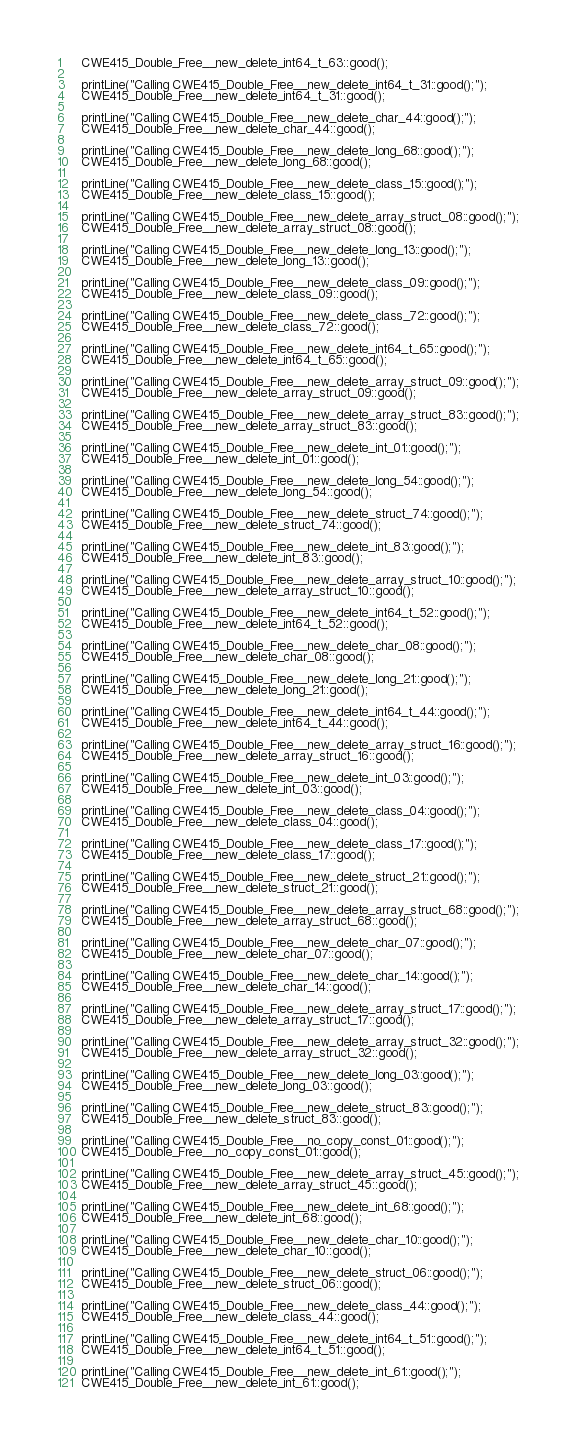<code> <loc_0><loc_0><loc_500><loc_500><_C++_>	CWE415_Double_Free__new_delete_int64_t_63::good();

	printLine("Calling CWE415_Double_Free__new_delete_int64_t_31::good();");
	CWE415_Double_Free__new_delete_int64_t_31::good();

	printLine("Calling CWE415_Double_Free__new_delete_char_44::good();");
	CWE415_Double_Free__new_delete_char_44::good();

	printLine("Calling CWE415_Double_Free__new_delete_long_68::good();");
	CWE415_Double_Free__new_delete_long_68::good();

	printLine("Calling CWE415_Double_Free__new_delete_class_15::good();");
	CWE415_Double_Free__new_delete_class_15::good();

	printLine("Calling CWE415_Double_Free__new_delete_array_struct_08::good();");
	CWE415_Double_Free__new_delete_array_struct_08::good();

	printLine("Calling CWE415_Double_Free__new_delete_long_13::good();");
	CWE415_Double_Free__new_delete_long_13::good();

	printLine("Calling CWE415_Double_Free__new_delete_class_09::good();");
	CWE415_Double_Free__new_delete_class_09::good();

	printLine("Calling CWE415_Double_Free__new_delete_class_72::good();");
	CWE415_Double_Free__new_delete_class_72::good();

	printLine("Calling CWE415_Double_Free__new_delete_int64_t_65::good();");
	CWE415_Double_Free__new_delete_int64_t_65::good();

	printLine("Calling CWE415_Double_Free__new_delete_array_struct_09::good();");
	CWE415_Double_Free__new_delete_array_struct_09::good();

	printLine("Calling CWE415_Double_Free__new_delete_array_struct_83::good();");
	CWE415_Double_Free__new_delete_array_struct_83::good();

	printLine("Calling CWE415_Double_Free__new_delete_int_01::good();");
	CWE415_Double_Free__new_delete_int_01::good();

	printLine("Calling CWE415_Double_Free__new_delete_long_54::good();");
	CWE415_Double_Free__new_delete_long_54::good();

	printLine("Calling CWE415_Double_Free__new_delete_struct_74::good();");
	CWE415_Double_Free__new_delete_struct_74::good();

	printLine("Calling CWE415_Double_Free__new_delete_int_83::good();");
	CWE415_Double_Free__new_delete_int_83::good();

	printLine("Calling CWE415_Double_Free__new_delete_array_struct_10::good();");
	CWE415_Double_Free__new_delete_array_struct_10::good();

	printLine("Calling CWE415_Double_Free__new_delete_int64_t_52::good();");
	CWE415_Double_Free__new_delete_int64_t_52::good();

	printLine("Calling CWE415_Double_Free__new_delete_char_08::good();");
	CWE415_Double_Free__new_delete_char_08::good();

	printLine("Calling CWE415_Double_Free__new_delete_long_21::good();");
	CWE415_Double_Free__new_delete_long_21::good();

	printLine("Calling CWE415_Double_Free__new_delete_int64_t_44::good();");
	CWE415_Double_Free__new_delete_int64_t_44::good();

	printLine("Calling CWE415_Double_Free__new_delete_array_struct_16::good();");
	CWE415_Double_Free__new_delete_array_struct_16::good();

	printLine("Calling CWE415_Double_Free__new_delete_int_03::good();");
	CWE415_Double_Free__new_delete_int_03::good();

	printLine("Calling CWE415_Double_Free__new_delete_class_04::good();");
	CWE415_Double_Free__new_delete_class_04::good();

	printLine("Calling CWE415_Double_Free__new_delete_class_17::good();");
	CWE415_Double_Free__new_delete_class_17::good();

	printLine("Calling CWE415_Double_Free__new_delete_struct_21::good();");
	CWE415_Double_Free__new_delete_struct_21::good();

	printLine("Calling CWE415_Double_Free__new_delete_array_struct_68::good();");
	CWE415_Double_Free__new_delete_array_struct_68::good();

	printLine("Calling CWE415_Double_Free__new_delete_char_07::good();");
	CWE415_Double_Free__new_delete_char_07::good();

	printLine("Calling CWE415_Double_Free__new_delete_char_14::good();");
	CWE415_Double_Free__new_delete_char_14::good();

	printLine("Calling CWE415_Double_Free__new_delete_array_struct_17::good();");
	CWE415_Double_Free__new_delete_array_struct_17::good();

	printLine("Calling CWE415_Double_Free__new_delete_array_struct_32::good();");
	CWE415_Double_Free__new_delete_array_struct_32::good();

	printLine("Calling CWE415_Double_Free__new_delete_long_03::good();");
	CWE415_Double_Free__new_delete_long_03::good();

	printLine("Calling CWE415_Double_Free__new_delete_struct_83::good();");
	CWE415_Double_Free__new_delete_struct_83::good();

	printLine("Calling CWE415_Double_Free__no_copy_const_01::good();");
	CWE415_Double_Free__no_copy_const_01::good();

	printLine("Calling CWE415_Double_Free__new_delete_array_struct_45::good();");
	CWE415_Double_Free__new_delete_array_struct_45::good();

	printLine("Calling CWE415_Double_Free__new_delete_int_68::good();");
	CWE415_Double_Free__new_delete_int_68::good();

	printLine("Calling CWE415_Double_Free__new_delete_char_10::good();");
	CWE415_Double_Free__new_delete_char_10::good();

	printLine("Calling CWE415_Double_Free__new_delete_struct_06::good();");
	CWE415_Double_Free__new_delete_struct_06::good();

	printLine("Calling CWE415_Double_Free__new_delete_class_44::good();");
	CWE415_Double_Free__new_delete_class_44::good();

	printLine("Calling CWE415_Double_Free__new_delete_int64_t_51::good();");
	CWE415_Double_Free__new_delete_int64_t_51::good();

	printLine("Calling CWE415_Double_Free__new_delete_int_61::good();");
	CWE415_Double_Free__new_delete_int_61::good();
</code> 